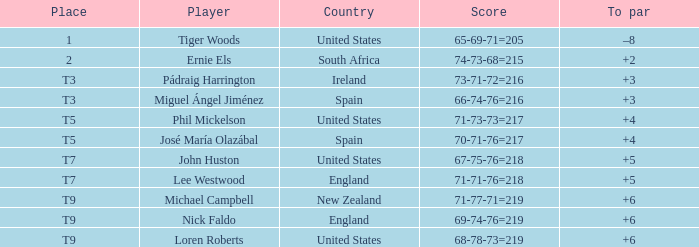Who is the player when the place is designated as "1"? Tiger Woods. 